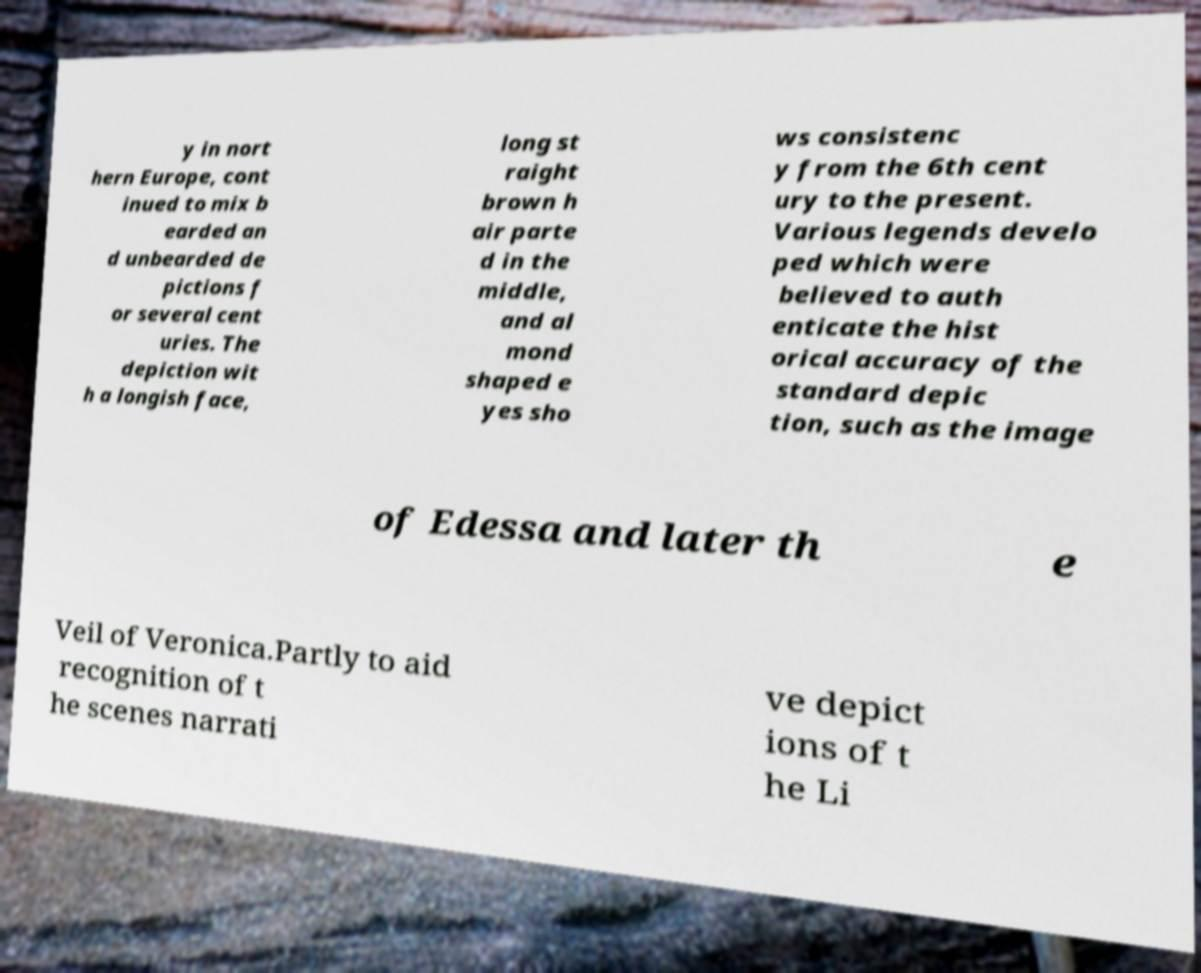Please read and relay the text visible in this image. What does it say? y in nort hern Europe, cont inued to mix b earded an d unbearded de pictions f or several cent uries. The depiction wit h a longish face, long st raight brown h air parte d in the middle, and al mond shaped e yes sho ws consistenc y from the 6th cent ury to the present. Various legends develo ped which were believed to auth enticate the hist orical accuracy of the standard depic tion, such as the image of Edessa and later th e Veil of Veronica.Partly to aid recognition of t he scenes narrati ve depict ions of t he Li 